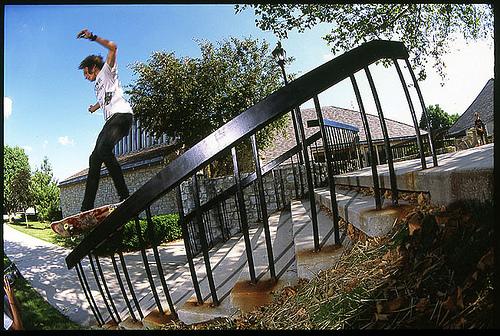Is the man walking the stairs?
Give a very brief answer. No. Is he going to fall?
Short answer required. No. Is the man wearing shorts or long pants?
Concise answer only. Long pants. 